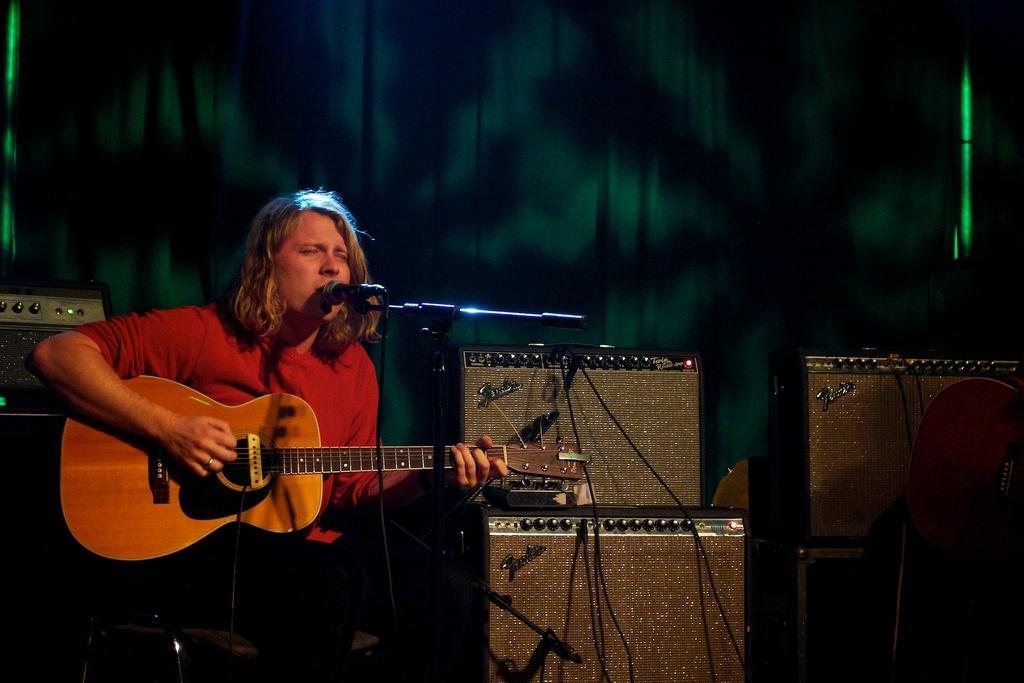How would you summarize this image in a sentence or two? In the left, a person is sitting on the chair and playing a guitar and singing a song in mike. The background is green and black in color. On the right bottom and left, speakers and sound boxes are visible. This image is taken on the stage during night time. 